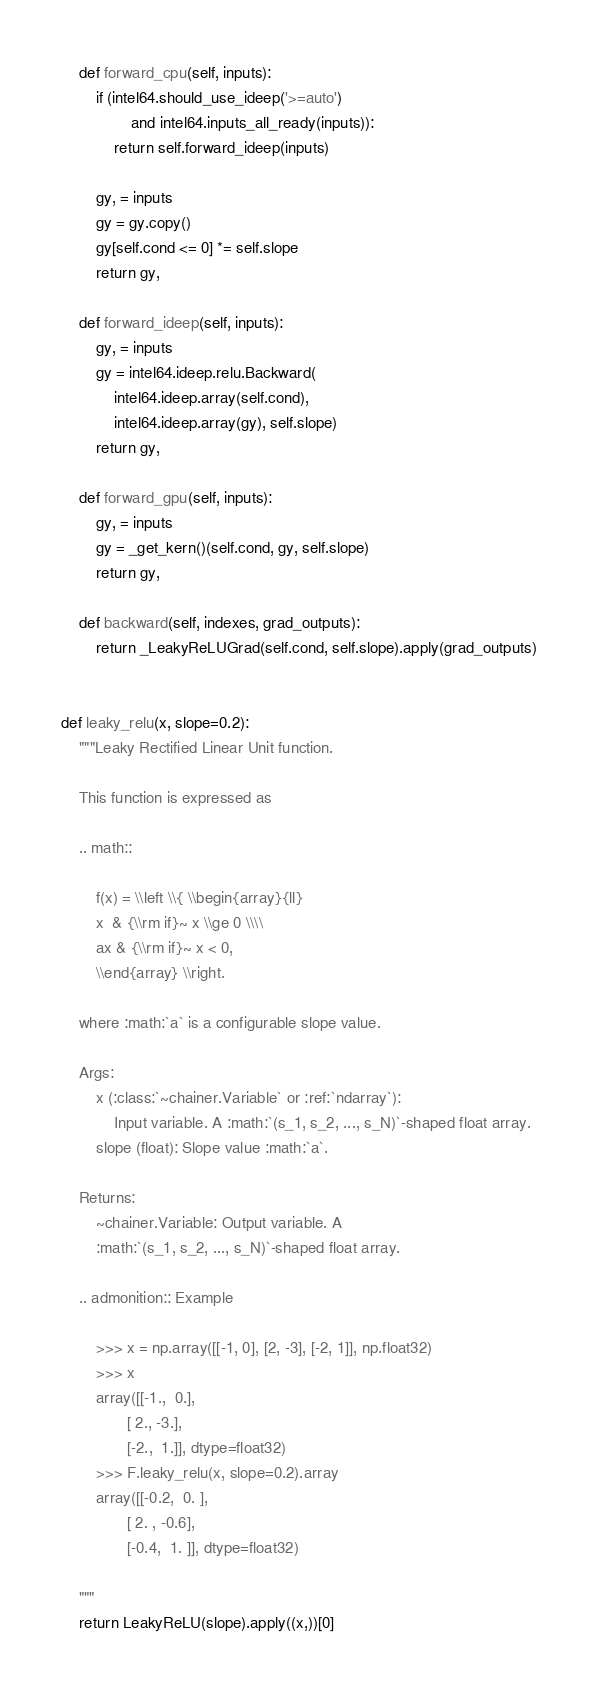<code> <loc_0><loc_0><loc_500><loc_500><_Python_>    def forward_cpu(self, inputs):
        if (intel64.should_use_ideep('>=auto')
                and intel64.inputs_all_ready(inputs)):
            return self.forward_ideep(inputs)

        gy, = inputs
        gy = gy.copy()
        gy[self.cond <= 0] *= self.slope
        return gy,

    def forward_ideep(self, inputs):
        gy, = inputs
        gy = intel64.ideep.relu.Backward(
            intel64.ideep.array(self.cond),
            intel64.ideep.array(gy), self.slope)
        return gy,

    def forward_gpu(self, inputs):
        gy, = inputs
        gy = _get_kern()(self.cond, gy, self.slope)
        return gy,

    def backward(self, indexes, grad_outputs):
        return _LeakyReLUGrad(self.cond, self.slope).apply(grad_outputs)


def leaky_relu(x, slope=0.2):
    """Leaky Rectified Linear Unit function.

    This function is expressed as

    .. math::

        f(x) = \\left \\{ \\begin{array}{ll}
        x  & {\\rm if}~ x \\ge 0 \\\\
        ax & {\\rm if}~ x < 0,
        \\end{array} \\right.

    where :math:`a` is a configurable slope value.

    Args:
        x (:class:`~chainer.Variable` or :ref:`ndarray`):
            Input variable. A :math:`(s_1, s_2, ..., s_N)`-shaped float array.
        slope (float): Slope value :math:`a`.

    Returns:
        ~chainer.Variable: Output variable. A
        :math:`(s_1, s_2, ..., s_N)`-shaped float array.

    .. admonition:: Example

        >>> x = np.array([[-1, 0], [2, -3], [-2, 1]], np.float32)
        >>> x
        array([[-1.,  0.],
               [ 2., -3.],
               [-2.,  1.]], dtype=float32)
        >>> F.leaky_relu(x, slope=0.2).array
        array([[-0.2,  0. ],
               [ 2. , -0.6],
               [-0.4,  1. ]], dtype=float32)

    """
    return LeakyReLU(slope).apply((x,))[0]
</code> 